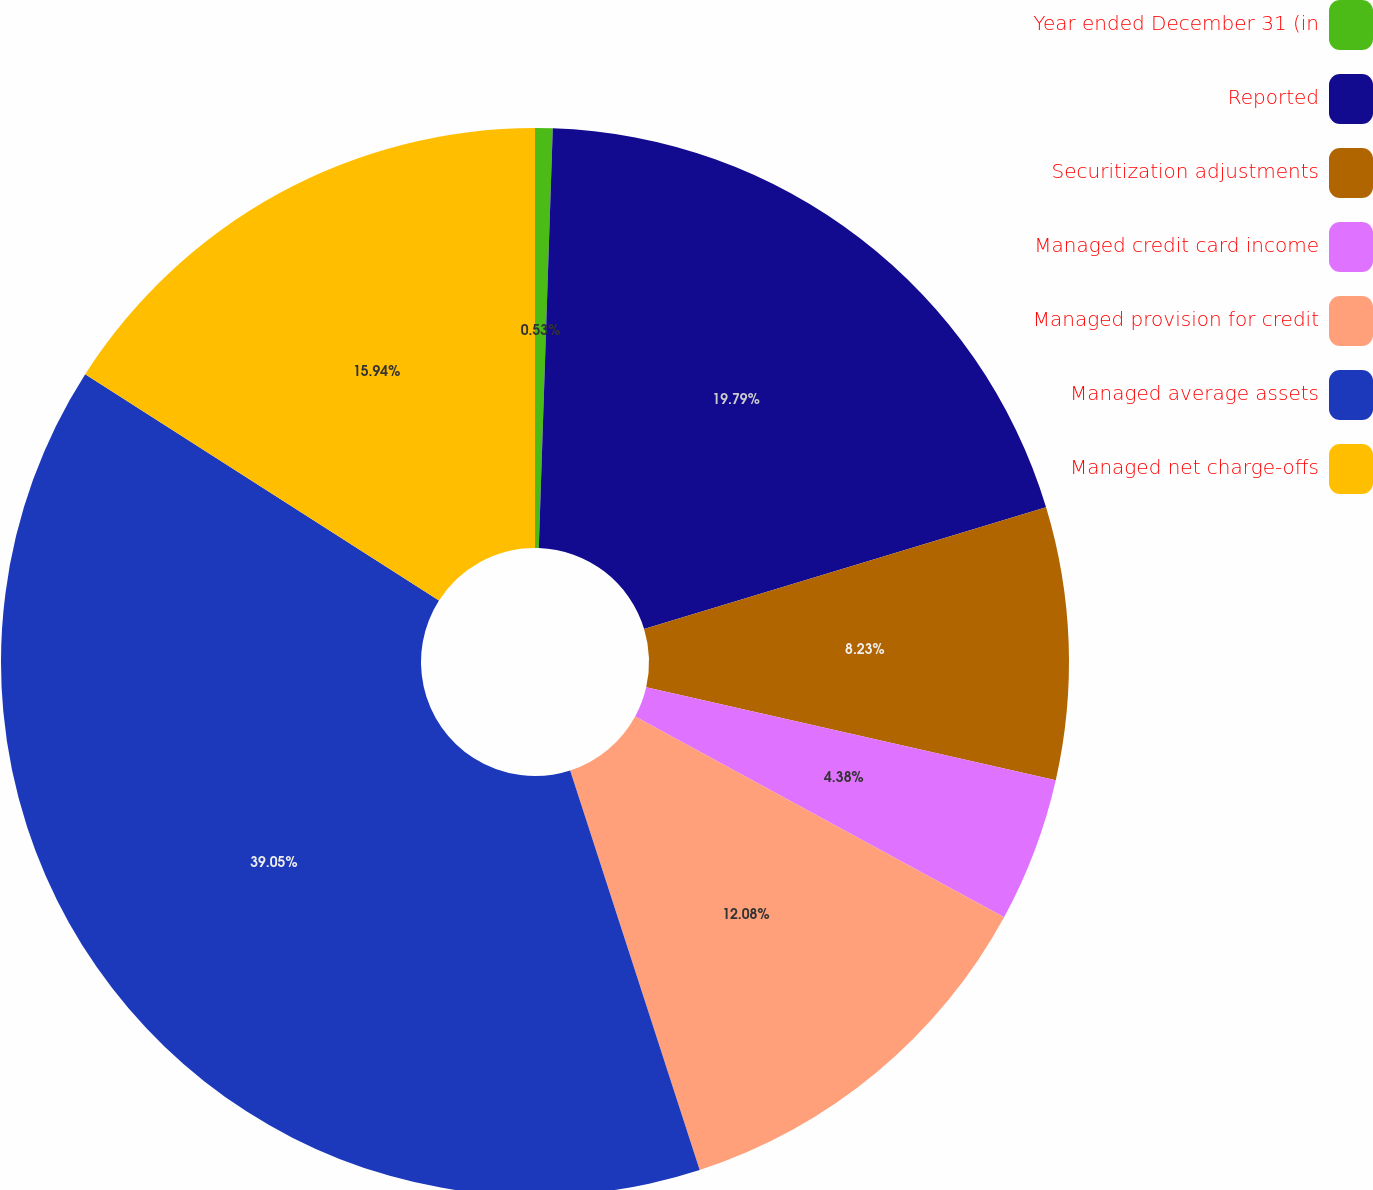<chart> <loc_0><loc_0><loc_500><loc_500><pie_chart><fcel>Year ended December 31 (in<fcel>Reported<fcel>Securitization adjustments<fcel>Managed credit card income<fcel>Managed provision for credit<fcel>Managed average assets<fcel>Managed net charge-offs<nl><fcel>0.53%<fcel>19.79%<fcel>8.23%<fcel>4.38%<fcel>12.08%<fcel>39.05%<fcel>15.94%<nl></chart> 